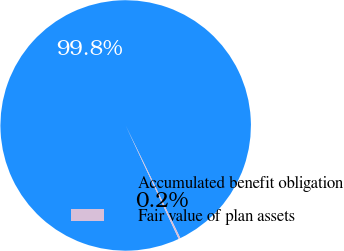<chart> <loc_0><loc_0><loc_500><loc_500><pie_chart><fcel>Accumulated benefit obligation<fcel>Fair value of plan assets<nl><fcel>99.77%<fcel>0.23%<nl></chart> 